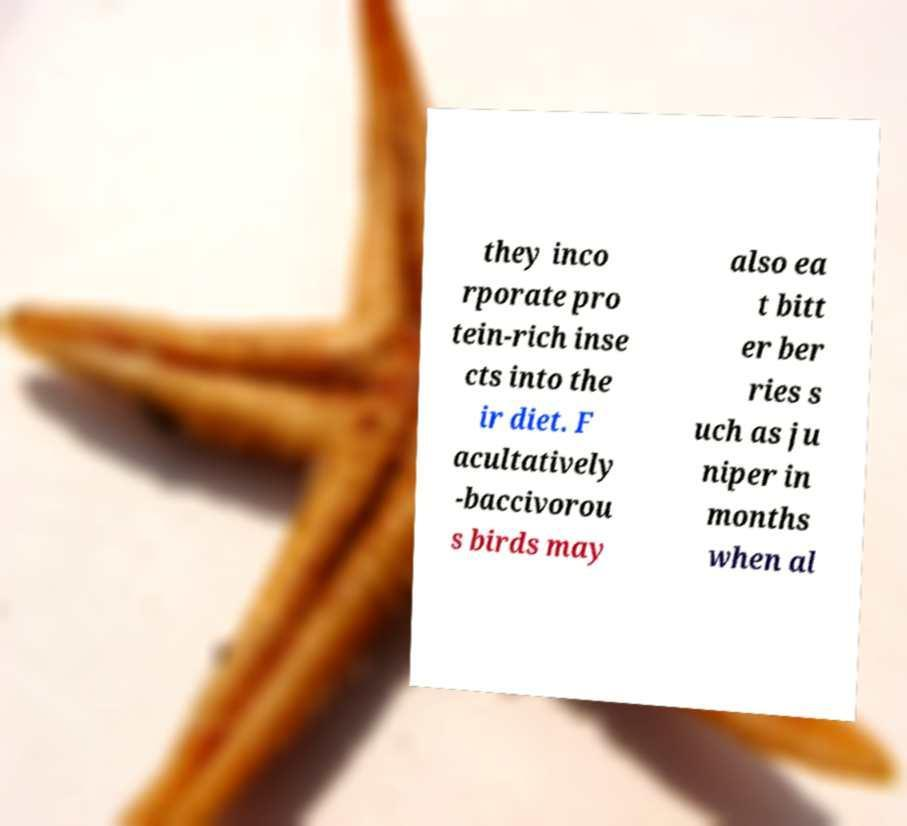For documentation purposes, I need the text within this image transcribed. Could you provide that? they inco rporate pro tein-rich inse cts into the ir diet. F acultatively -baccivorou s birds may also ea t bitt er ber ries s uch as ju niper in months when al 